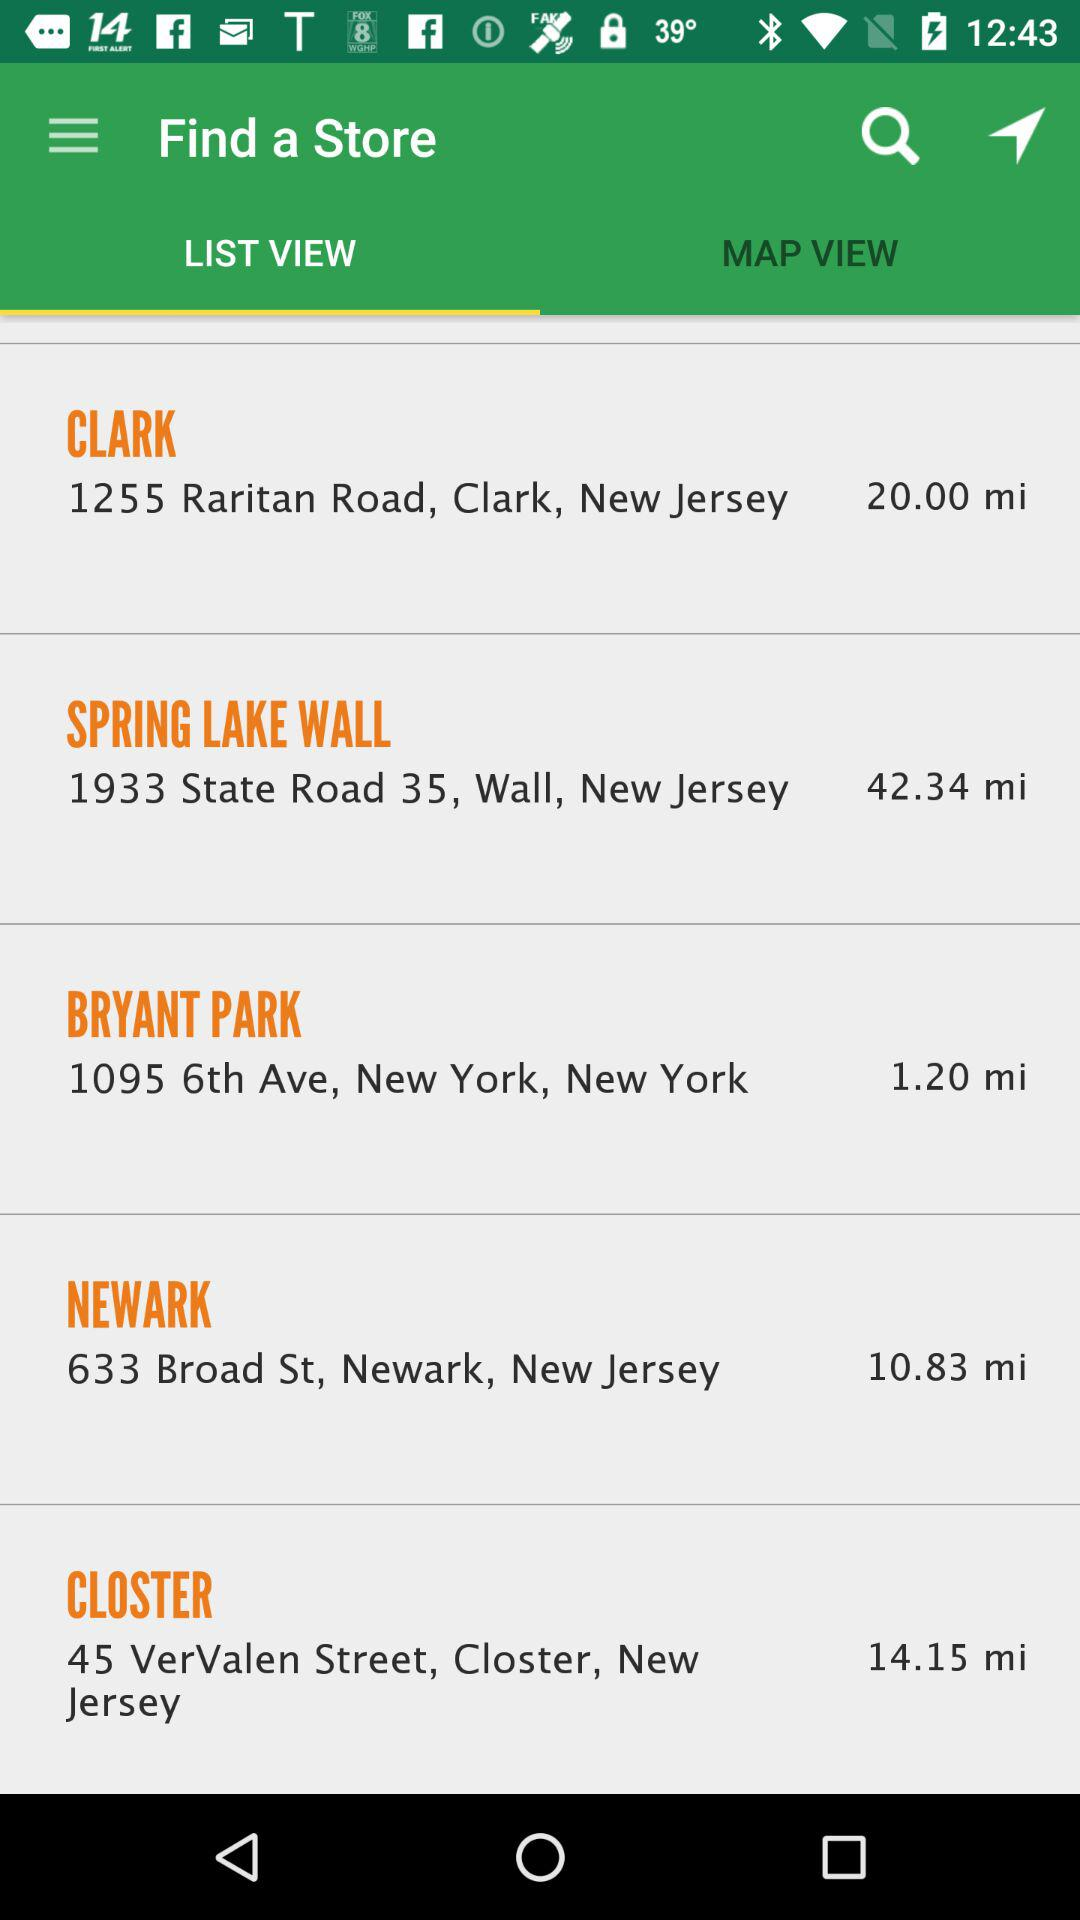What is the location of Newark? The location of Newark is 633 Broad St, Newark, New Jersey. 